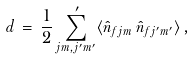<formula> <loc_0><loc_0><loc_500><loc_500>d \, = \, \frac { 1 } { 2 } \sum _ { j m , j ^ { \prime } m ^ { \prime } } ^ { \, \prime } \langle \hat { n } _ { f j m } \, \hat { n } _ { f j ^ { \prime } m ^ { \prime } } \rangle \, ,</formula> 